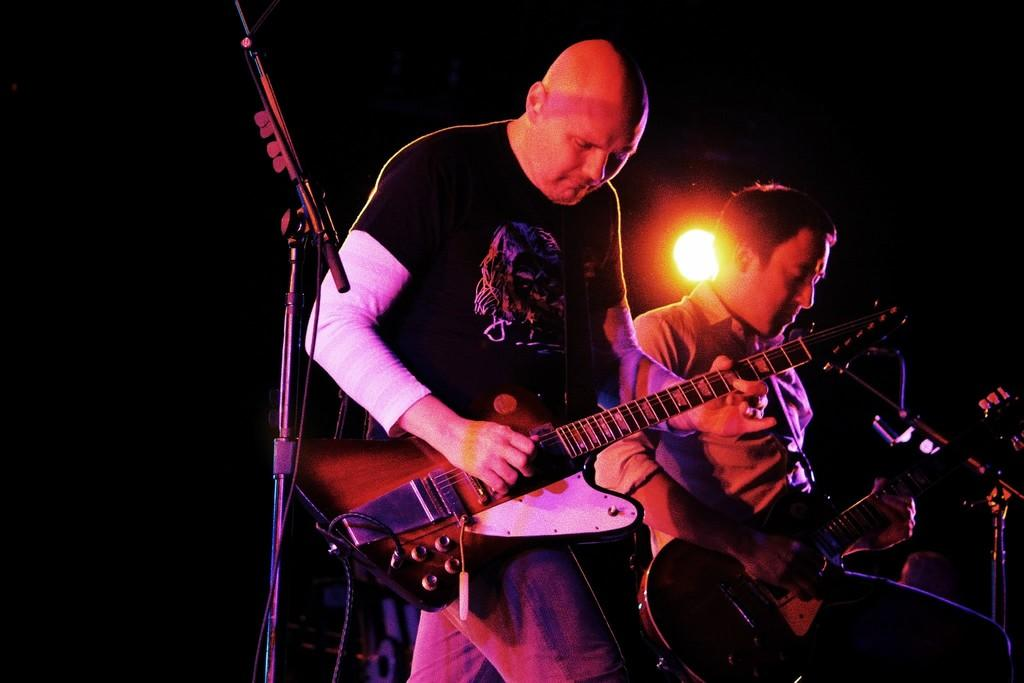How many people are on the stage in the image? There are two men on the stage in the image. What are the men doing on the stage? The men are playing musical instruments. What object is present on the stage? There is a microphone with a stand in the image. How many legs can be seen on the stage in the image? There is no information about legs in the image. 